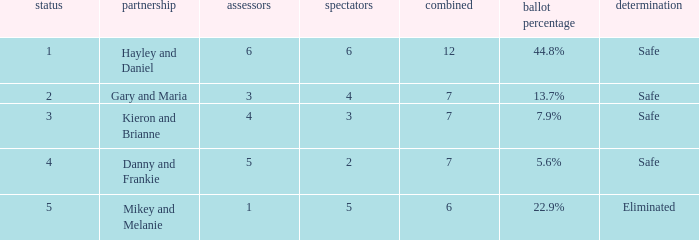What is the number of public that was there when the vote percentage was 22.9%? 1.0. 